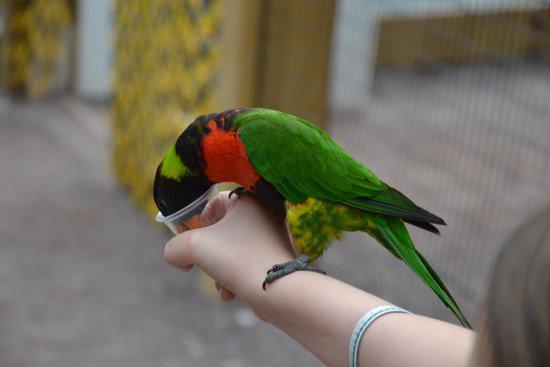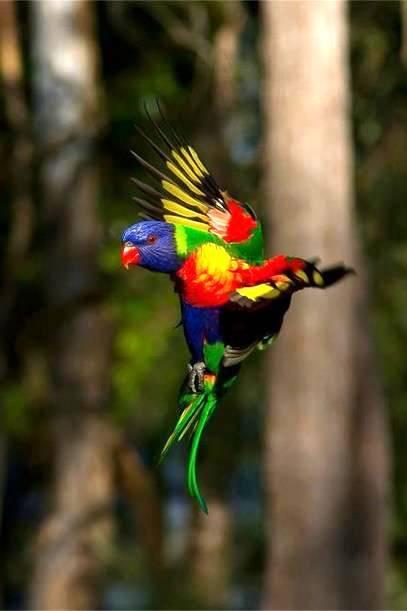The first image is the image on the left, the second image is the image on the right. Evaluate the accuracy of this statement regarding the images: "There are a total of three birds". Is it true? Answer yes or no. No. The first image is the image on the left, the second image is the image on the right. Considering the images on both sides, is "Two birds in one image have matching head coloring, while the other image shows at least one bird with a purple head." valid? Answer yes or no. No. 